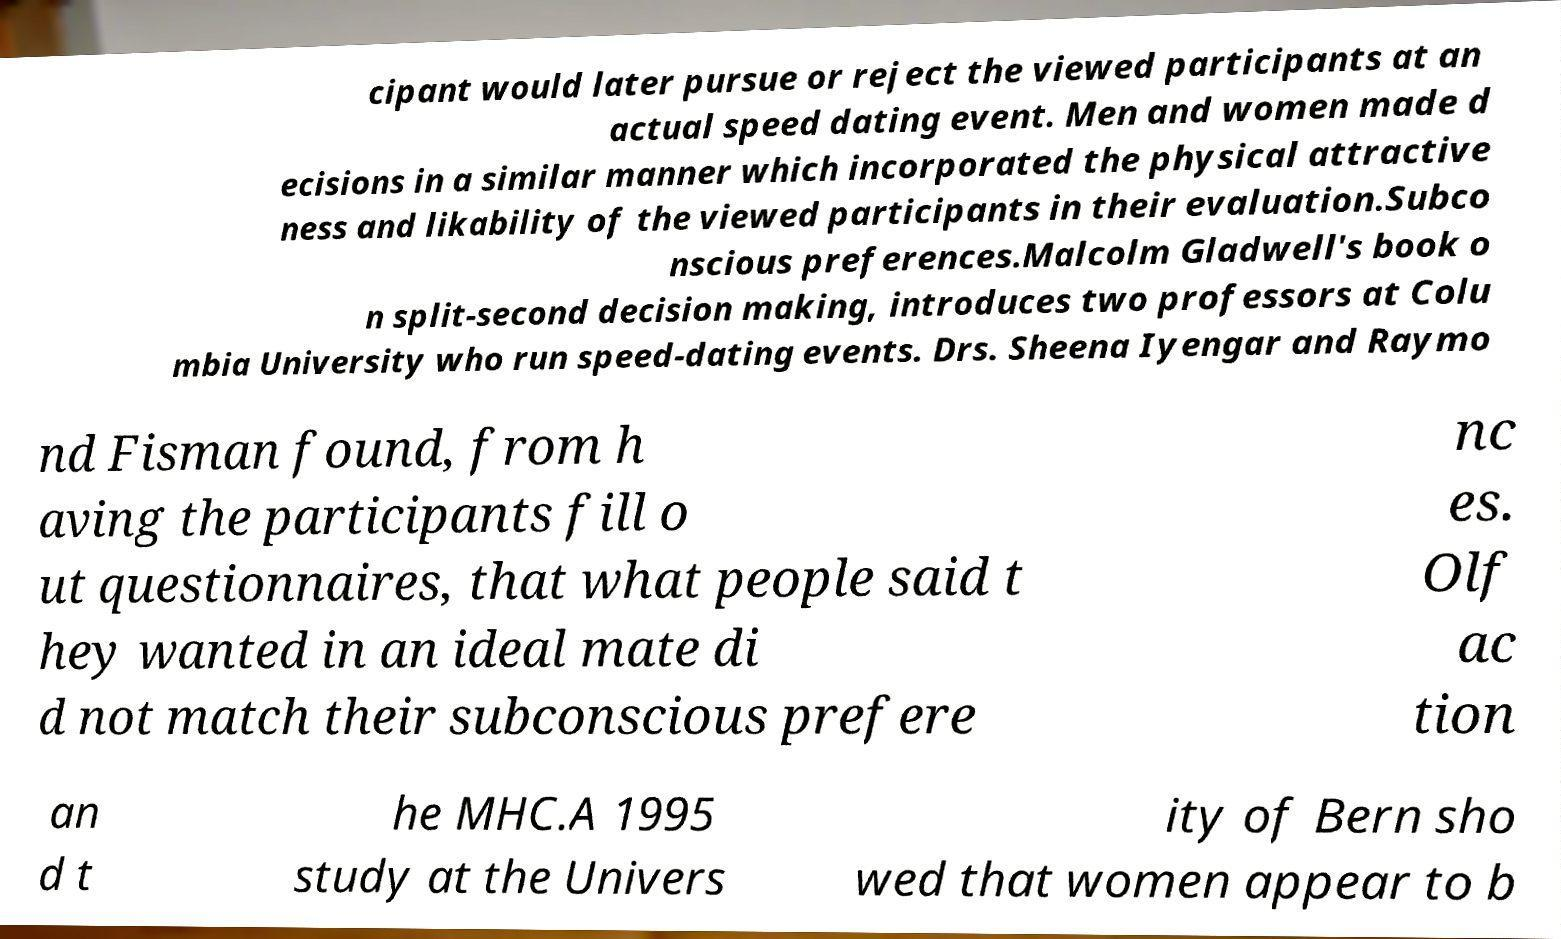Can you accurately transcribe the text from the provided image for me? cipant would later pursue or reject the viewed participants at an actual speed dating event. Men and women made d ecisions in a similar manner which incorporated the physical attractive ness and likability of the viewed participants in their evaluation.Subco nscious preferences.Malcolm Gladwell's book o n split-second decision making, introduces two professors at Colu mbia University who run speed-dating events. Drs. Sheena Iyengar and Raymo nd Fisman found, from h aving the participants fill o ut questionnaires, that what people said t hey wanted in an ideal mate di d not match their subconscious prefere nc es. Olf ac tion an d t he MHC.A 1995 study at the Univers ity of Bern sho wed that women appear to b 